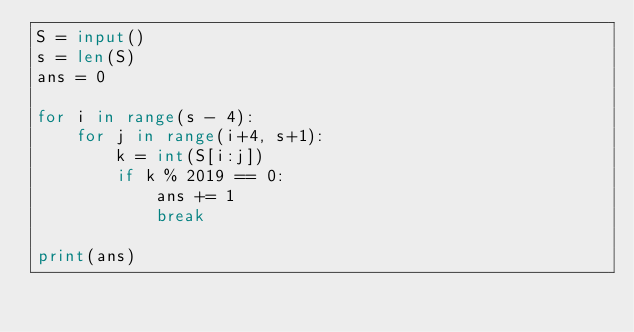Convert code to text. <code><loc_0><loc_0><loc_500><loc_500><_Python_>S = input()
s = len(S)
ans = 0

for i in range(s - 4):
    for j in range(i+4, s+1):
        k = int(S[i:j])
        if k % 2019 == 0:
            ans += 1
            break

print(ans)
</code> 